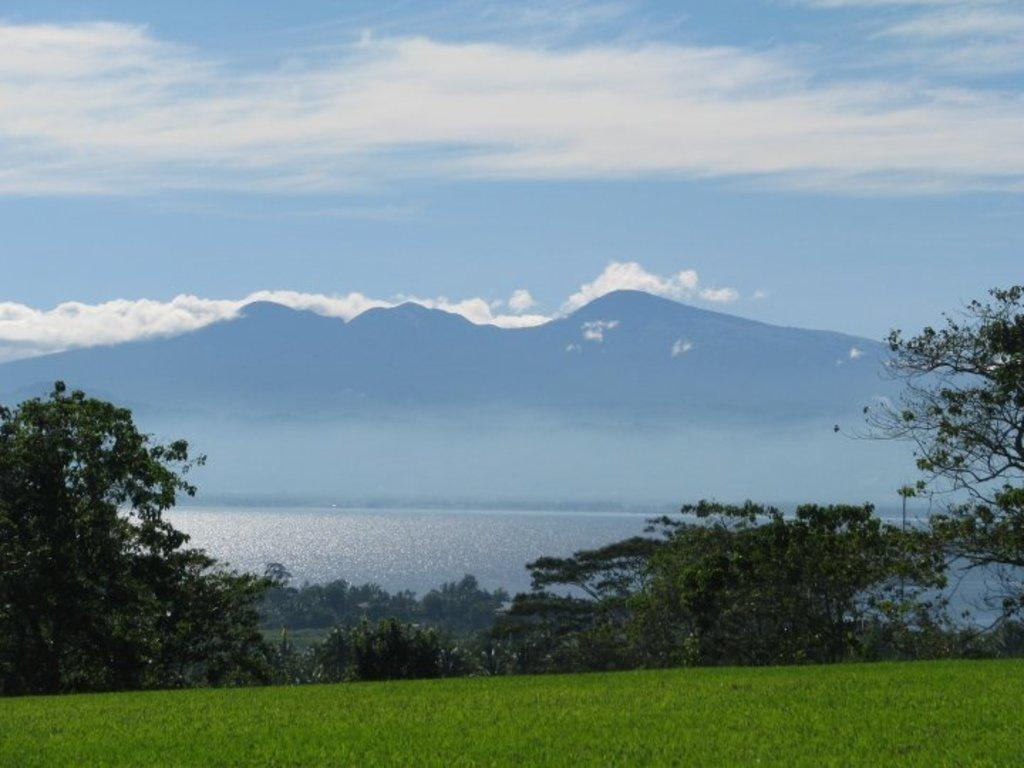What type of vegetation can be seen in the image? There are trees in the image. What else can be seen on the ground in the image? There is grass in the image. What geographical features are present in the image? There are mountains in the image. What is the body of water visible in the image? There is water visible in the image. What is the color of the sky in the image? The sky is blue and white in color. What type of letters can be seen floating in the water in the image? There are no letters visible in the image, and therefore none can be seen floating in the water. 